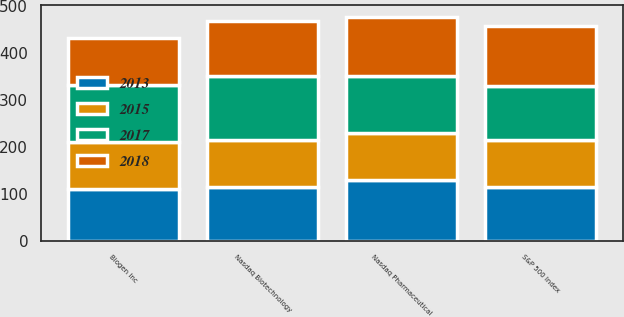Convert chart. <chart><loc_0><loc_0><loc_500><loc_500><stacked_bar_chart><ecel><fcel>Biogen Inc<fcel>Nasdaq Pharmaceutical<fcel>S&P 500 Index<fcel>Nasdaq Biotechnology<nl><fcel>2015<fcel>100<fcel>100<fcel>100<fcel>100<nl><fcel>2017<fcel>121.42<fcel>121.82<fcel>113.69<fcel>134.4<nl><fcel>2013<fcel>109.58<fcel>128.44<fcel>115.26<fcel>115.26<nl><fcel>2018<fcel>101.43<fcel>127.04<fcel>129.05<fcel>118.15<nl></chart> 